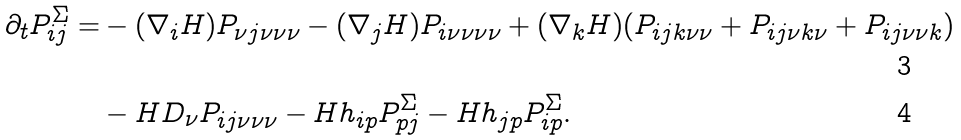<formula> <loc_0><loc_0><loc_500><loc_500>\partial _ { t } P ^ { \Sigma } _ { i j } = & - ( \nabla _ { i } H ) P _ { \nu j \nu \nu \nu } - ( \nabla _ { j } H ) P _ { i \nu \nu \nu \nu } + ( \nabla _ { k } H ) ( P _ { i j k \nu \nu } + P _ { i j \nu k \nu } + P _ { i j \nu \nu k } ) \\ & - H D _ { \nu } P _ { i j \nu \nu \nu } - H h _ { i p } P ^ { \Sigma } _ { p j } - H h _ { j p } P ^ { \Sigma } _ { i p } .</formula> 